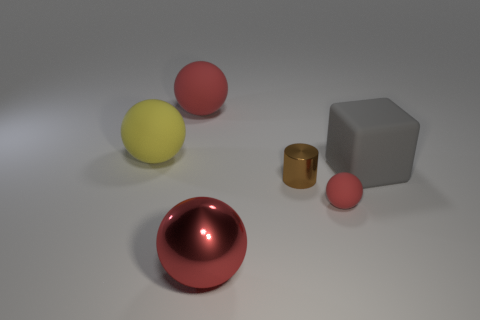There is a large red object behind the big red metal sphere; what shape is it?
Keep it short and to the point. Sphere. Is the number of big red metallic spheres greater than the number of red balls?
Provide a succinct answer. No. There is a big thing in front of the tiny ball; is it the same color as the small rubber ball?
Keep it short and to the point. Yes. What number of things are either things that are in front of the big gray object or red things behind the yellow matte thing?
Ensure brevity in your answer.  4. How many big matte things are both in front of the large yellow rubber sphere and behind the cube?
Give a very brief answer. 0. Do the large yellow ball and the gray thing have the same material?
Your response must be concise. Yes. The big yellow thing that is in front of the red thing on the left side of the red sphere that is in front of the small red matte object is what shape?
Offer a very short reply. Sphere. There is a object that is in front of the large red rubber ball and behind the big block; what material is it made of?
Provide a short and direct response. Rubber. There is a big rubber thing that is in front of the object that is on the left side of the red sphere that is behind the tiny red matte thing; what is its color?
Your answer should be compact. Gray. How many gray things are either rubber things or matte cubes?
Offer a very short reply. 1. 